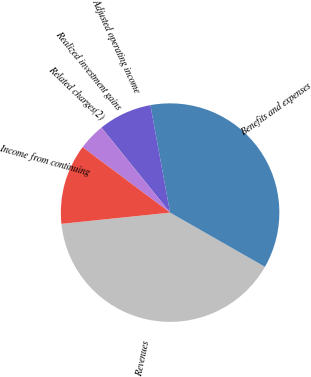<chart> <loc_0><loc_0><loc_500><loc_500><pie_chart><fcel>Revenues<fcel>Benefits and expenses<fcel>Adjusted operating income<fcel>Realized investment gains<fcel>Related charges(2)<fcel>Income from continuing<nl><fcel>40.1%<fcel>36.15%<fcel>7.91%<fcel>0.02%<fcel>3.96%<fcel>11.86%<nl></chart> 